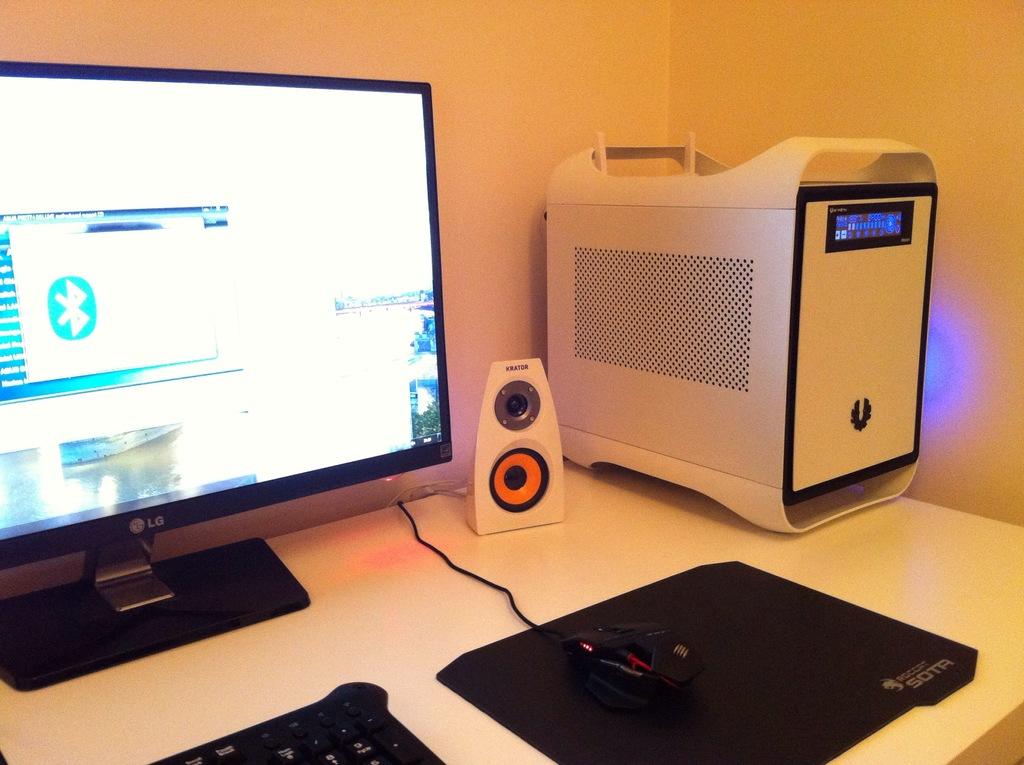What brand of mouse pad is this?
Offer a terse response. Sota. What brand of monitor is this computer?
Make the answer very short. Lg. 